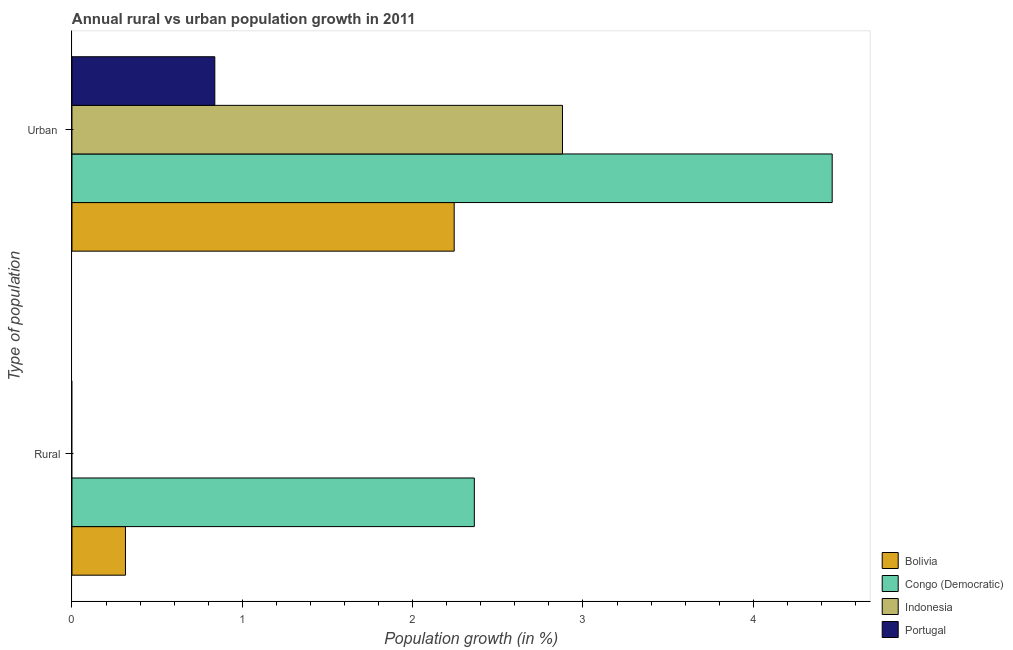How many different coloured bars are there?
Provide a short and direct response. 4. Are the number of bars per tick equal to the number of legend labels?
Your response must be concise. No. Are the number of bars on each tick of the Y-axis equal?
Offer a terse response. No. How many bars are there on the 2nd tick from the top?
Provide a short and direct response. 2. What is the label of the 1st group of bars from the top?
Offer a terse response. Urban . What is the urban population growth in Bolivia?
Your answer should be compact. 2.24. Across all countries, what is the maximum urban population growth?
Your answer should be very brief. 4.46. Across all countries, what is the minimum urban population growth?
Offer a very short reply. 0.84. In which country was the urban population growth maximum?
Your answer should be very brief. Congo (Democratic). What is the total rural population growth in the graph?
Give a very brief answer. 2.68. What is the difference between the urban population growth in Congo (Democratic) and that in Indonesia?
Your answer should be compact. 1.58. What is the difference between the rural population growth in Indonesia and the urban population growth in Bolivia?
Your answer should be compact. -2.24. What is the average rural population growth per country?
Your response must be concise. 0.67. What is the difference between the urban population growth and rural population growth in Bolivia?
Offer a very short reply. 1.93. What is the ratio of the urban population growth in Bolivia to that in Portugal?
Make the answer very short. 2.68. Is the urban population growth in Congo (Democratic) less than that in Portugal?
Keep it short and to the point. No. In how many countries, is the urban population growth greater than the average urban population growth taken over all countries?
Offer a terse response. 2. How many countries are there in the graph?
Ensure brevity in your answer.  4. Are the values on the major ticks of X-axis written in scientific E-notation?
Provide a short and direct response. No. Where does the legend appear in the graph?
Your answer should be very brief. Bottom right. How many legend labels are there?
Your answer should be very brief. 4. What is the title of the graph?
Your answer should be compact. Annual rural vs urban population growth in 2011. Does "St. Kitts and Nevis" appear as one of the legend labels in the graph?
Your response must be concise. No. What is the label or title of the X-axis?
Your answer should be very brief. Population growth (in %). What is the label or title of the Y-axis?
Provide a short and direct response. Type of population. What is the Population growth (in %) of Bolivia in Rural?
Make the answer very short. 0.31. What is the Population growth (in %) in Congo (Democratic) in Rural?
Your answer should be compact. 2.36. What is the Population growth (in %) in Indonesia in Rural?
Offer a very short reply. 0. What is the Population growth (in %) of Bolivia in Urban ?
Provide a succinct answer. 2.24. What is the Population growth (in %) of Congo (Democratic) in Urban ?
Keep it short and to the point. 4.46. What is the Population growth (in %) of Indonesia in Urban ?
Your answer should be very brief. 2.88. What is the Population growth (in %) of Portugal in Urban ?
Keep it short and to the point. 0.84. Across all Type of population, what is the maximum Population growth (in %) in Bolivia?
Your answer should be compact. 2.24. Across all Type of population, what is the maximum Population growth (in %) of Congo (Democratic)?
Make the answer very short. 4.46. Across all Type of population, what is the maximum Population growth (in %) of Indonesia?
Keep it short and to the point. 2.88. Across all Type of population, what is the maximum Population growth (in %) of Portugal?
Provide a succinct answer. 0.84. Across all Type of population, what is the minimum Population growth (in %) in Bolivia?
Provide a short and direct response. 0.31. Across all Type of population, what is the minimum Population growth (in %) of Congo (Democratic)?
Provide a succinct answer. 2.36. What is the total Population growth (in %) of Bolivia in the graph?
Provide a succinct answer. 2.56. What is the total Population growth (in %) in Congo (Democratic) in the graph?
Your response must be concise. 6.83. What is the total Population growth (in %) in Indonesia in the graph?
Give a very brief answer. 2.88. What is the total Population growth (in %) in Portugal in the graph?
Your answer should be very brief. 0.84. What is the difference between the Population growth (in %) of Bolivia in Rural and that in Urban ?
Your response must be concise. -1.93. What is the difference between the Population growth (in %) of Congo (Democratic) in Rural and that in Urban ?
Offer a terse response. -2.1. What is the difference between the Population growth (in %) in Bolivia in Rural and the Population growth (in %) in Congo (Democratic) in Urban ?
Offer a terse response. -4.15. What is the difference between the Population growth (in %) of Bolivia in Rural and the Population growth (in %) of Indonesia in Urban ?
Keep it short and to the point. -2.57. What is the difference between the Population growth (in %) in Bolivia in Rural and the Population growth (in %) in Portugal in Urban ?
Make the answer very short. -0.52. What is the difference between the Population growth (in %) of Congo (Democratic) in Rural and the Population growth (in %) of Indonesia in Urban ?
Provide a succinct answer. -0.52. What is the difference between the Population growth (in %) in Congo (Democratic) in Rural and the Population growth (in %) in Portugal in Urban ?
Give a very brief answer. 1.52. What is the average Population growth (in %) of Bolivia per Type of population?
Make the answer very short. 1.28. What is the average Population growth (in %) in Congo (Democratic) per Type of population?
Offer a terse response. 3.41. What is the average Population growth (in %) of Indonesia per Type of population?
Your response must be concise. 1.44. What is the average Population growth (in %) in Portugal per Type of population?
Keep it short and to the point. 0.42. What is the difference between the Population growth (in %) of Bolivia and Population growth (in %) of Congo (Democratic) in Rural?
Make the answer very short. -2.05. What is the difference between the Population growth (in %) in Bolivia and Population growth (in %) in Congo (Democratic) in Urban ?
Make the answer very short. -2.22. What is the difference between the Population growth (in %) of Bolivia and Population growth (in %) of Indonesia in Urban ?
Offer a very short reply. -0.64. What is the difference between the Population growth (in %) of Bolivia and Population growth (in %) of Portugal in Urban ?
Make the answer very short. 1.41. What is the difference between the Population growth (in %) in Congo (Democratic) and Population growth (in %) in Indonesia in Urban ?
Your response must be concise. 1.58. What is the difference between the Population growth (in %) in Congo (Democratic) and Population growth (in %) in Portugal in Urban ?
Provide a succinct answer. 3.62. What is the difference between the Population growth (in %) in Indonesia and Population growth (in %) in Portugal in Urban ?
Your answer should be very brief. 2.04. What is the ratio of the Population growth (in %) of Bolivia in Rural to that in Urban ?
Provide a succinct answer. 0.14. What is the ratio of the Population growth (in %) of Congo (Democratic) in Rural to that in Urban ?
Offer a terse response. 0.53. What is the difference between the highest and the second highest Population growth (in %) of Bolivia?
Give a very brief answer. 1.93. What is the difference between the highest and the second highest Population growth (in %) of Congo (Democratic)?
Ensure brevity in your answer.  2.1. What is the difference between the highest and the lowest Population growth (in %) of Bolivia?
Ensure brevity in your answer.  1.93. What is the difference between the highest and the lowest Population growth (in %) of Congo (Democratic)?
Give a very brief answer. 2.1. What is the difference between the highest and the lowest Population growth (in %) of Indonesia?
Your answer should be compact. 2.88. What is the difference between the highest and the lowest Population growth (in %) of Portugal?
Offer a terse response. 0.84. 